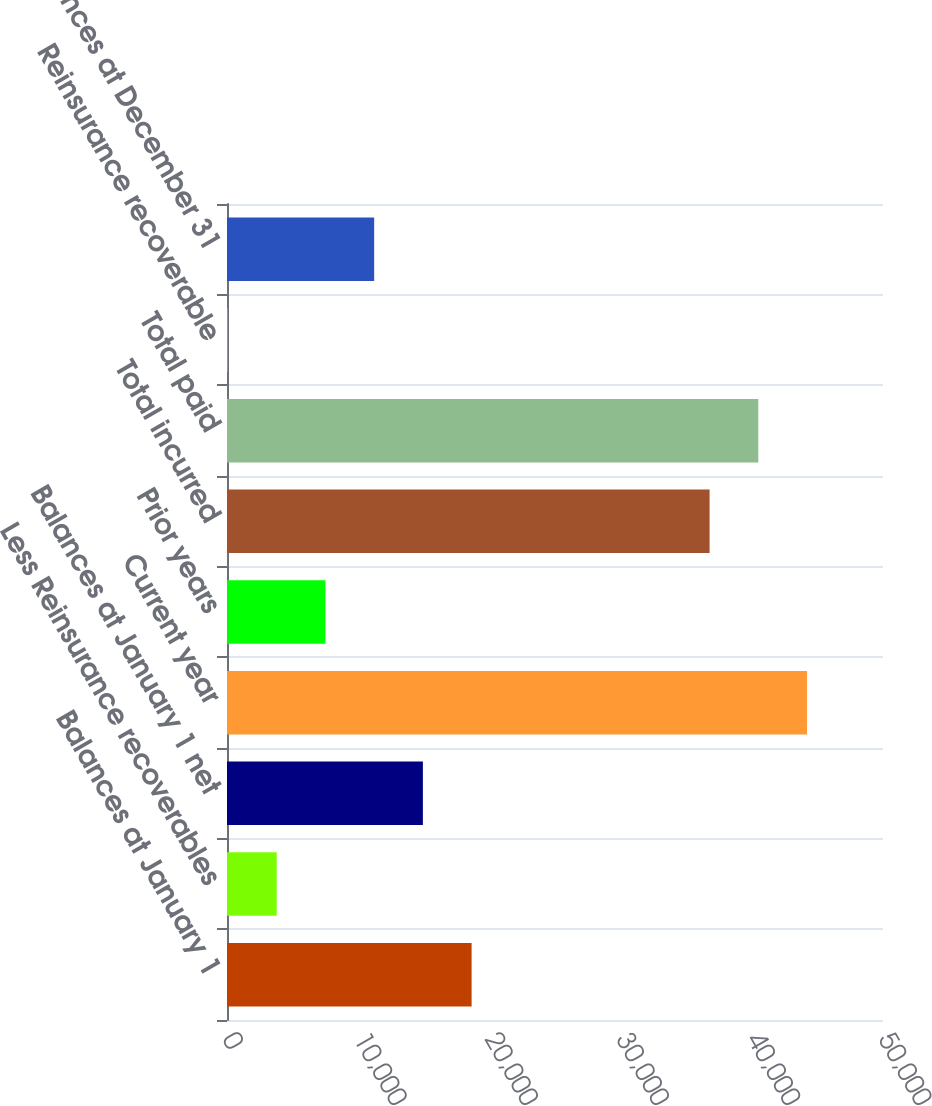<chart> <loc_0><loc_0><loc_500><loc_500><bar_chart><fcel>Balances at January 1<fcel>Less Reinsurance recoverables<fcel>Balances at January 1 net<fcel>Current year<fcel>Prior years<fcel>Total incurred<fcel>Total paid<fcel>Reinsurance recoverable<fcel>Balances at December 31<nl><fcel>18644<fcel>3789.6<fcel>14930.4<fcel>44210.2<fcel>7503.2<fcel>36783<fcel>40496.6<fcel>76<fcel>11216.8<nl></chart> 